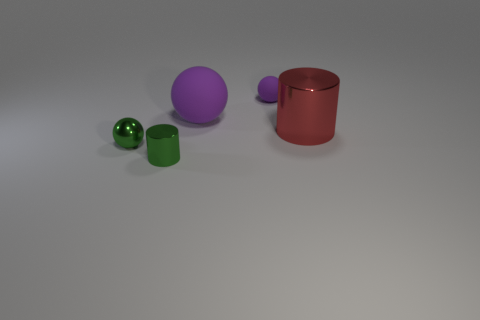Is the color of the tiny thing in front of the small green metallic sphere the same as the small metallic ball?
Your answer should be very brief. Yes. What number of objects are either red objects or big red cylinders that are in front of the small purple matte sphere?
Offer a terse response. 1. Is there a purple matte sphere?
Provide a short and direct response. Yes. How many rubber balls have the same color as the small matte object?
Provide a succinct answer. 1. There is a big sphere that is the same color as the tiny rubber object; what material is it?
Your answer should be very brief. Rubber. There is a cylinder that is behind the tiny ball that is in front of the large purple rubber sphere; what is its size?
Keep it short and to the point. Large. Are there any other cylinders made of the same material as the red cylinder?
Give a very brief answer. Yes. There is a purple object that is the same size as the green cylinder; what is its material?
Your answer should be compact. Rubber. There is a small thing that is behind the big shiny cylinder; is it the same color as the big thing behind the large red object?
Ensure brevity in your answer.  Yes. There is a cylinder that is in front of the large red shiny cylinder; are there any purple spheres right of it?
Provide a short and direct response. Yes. 